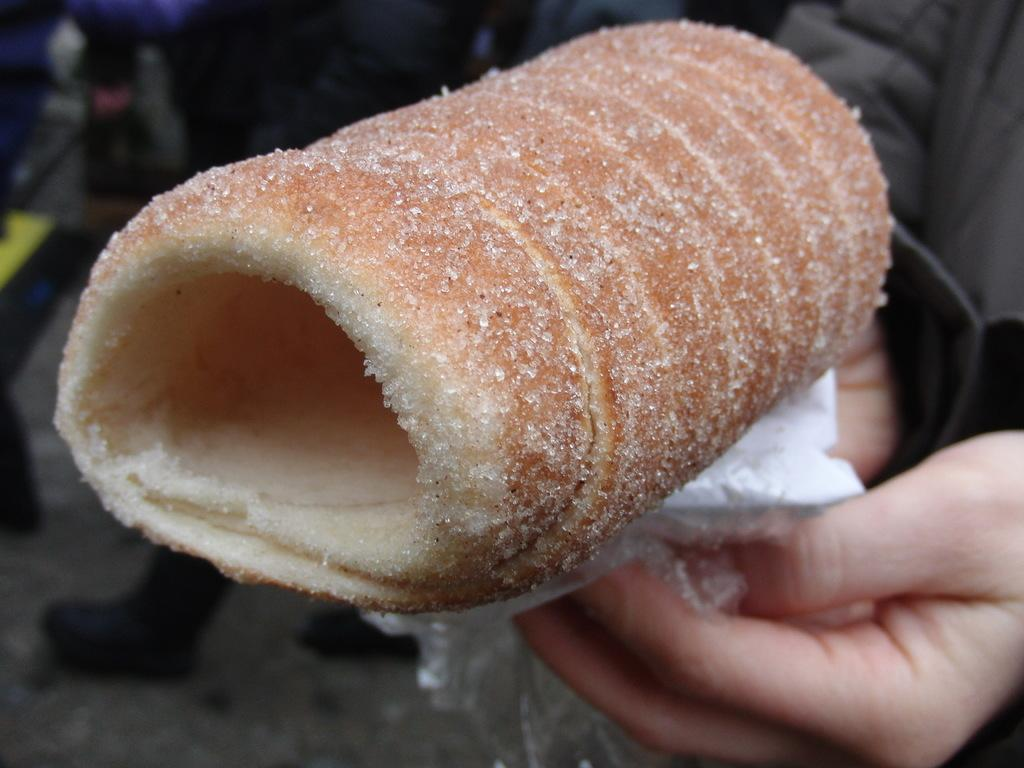What objects are being held by the human hands in the image? There are human hands with tissue in the image. What else can be seen in the image besides the hands and tissue? There is food visible in the image. Can you describe the background of the image? The background of the image is blurred. What is happening in the background of the image? There are people on the road in the background of the image. What language is being spoken by the people on the road in the image? The image does not provide any information about the language being spoken by the people on the road. 